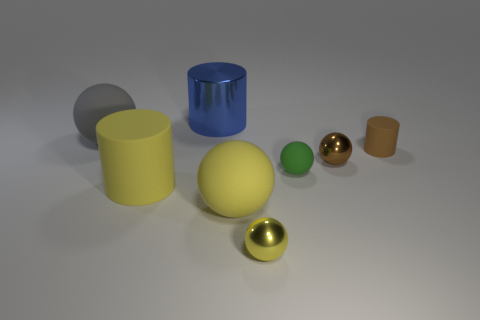Do the large yellow thing that is on the right side of the big metal cylinder and the brown metallic thing have the same shape?
Offer a terse response. Yes. What is the small yellow object made of?
Ensure brevity in your answer.  Metal. What is the shape of the blue shiny object that is the same size as the gray object?
Offer a terse response. Cylinder. Are there any big spheres that have the same color as the metal cylinder?
Your response must be concise. No. Do the large matte cylinder and the shiny object that is to the right of the small yellow sphere have the same color?
Ensure brevity in your answer.  No. There is a tiny sphere that is in front of the big rubber sphere to the right of the large metallic cylinder; what color is it?
Provide a succinct answer. Yellow. Are there any gray rubber spheres left of the large matte sphere that is right of the large metal cylinder behind the yellow metal object?
Ensure brevity in your answer.  Yes. What is the color of the tiny sphere that is the same material as the yellow cylinder?
Your answer should be compact. Green. What number of green spheres have the same material as the large blue cylinder?
Your answer should be compact. 0. Is the tiny green ball made of the same material as the sphere that is on the left side of the large yellow ball?
Offer a terse response. Yes. 